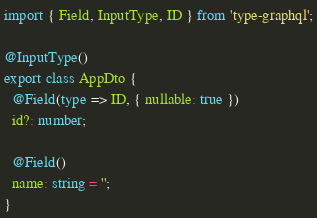Convert code to text. <code><loc_0><loc_0><loc_500><loc_500><_TypeScript_>import { Field, InputType, ID } from 'type-graphql';

@InputType()
export class AppDto {
  @Field(type => ID, { nullable: true })
  id?: number;

  @Field()
  name: string = '';
}
</code> 